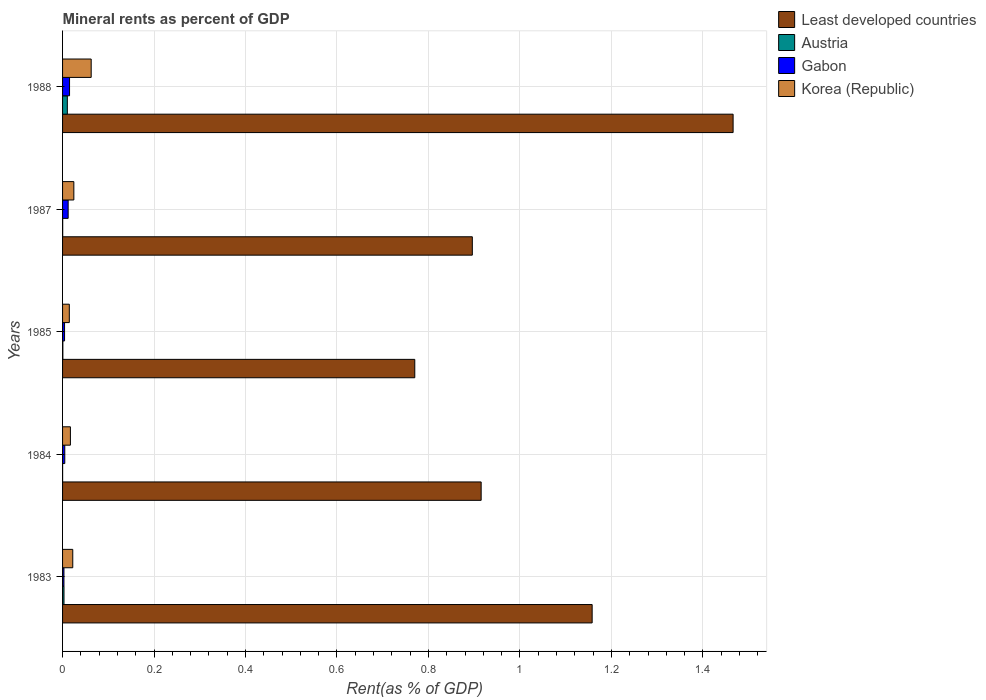How many different coloured bars are there?
Your answer should be very brief. 4. How many groups of bars are there?
Provide a succinct answer. 5. Are the number of bars on each tick of the Y-axis equal?
Provide a short and direct response. Yes. How many bars are there on the 3rd tick from the top?
Make the answer very short. 4. What is the label of the 2nd group of bars from the top?
Give a very brief answer. 1987. In how many cases, is the number of bars for a given year not equal to the number of legend labels?
Offer a very short reply. 0. What is the mineral rent in Least developed countries in 1987?
Your response must be concise. 0.9. Across all years, what is the maximum mineral rent in Least developed countries?
Offer a very short reply. 1.47. Across all years, what is the minimum mineral rent in Austria?
Provide a succinct answer. 8.70112299928104e-5. What is the total mineral rent in Least developed countries in the graph?
Give a very brief answer. 5.21. What is the difference between the mineral rent in Least developed countries in 1984 and that in 1987?
Keep it short and to the point. 0.02. What is the difference between the mineral rent in Korea (Republic) in 1988 and the mineral rent in Least developed countries in 1984?
Give a very brief answer. -0.85. What is the average mineral rent in Korea (Republic) per year?
Make the answer very short. 0.03. In the year 1985, what is the difference between the mineral rent in Gabon and mineral rent in Austria?
Offer a terse response. 0. What is the ratio of the mineral rent in Austria in 1987 to that in 1988?
Provide a short and direct response. 0.02. What is the difference between the highest and the second highest mineral rent in Korea (Republic)?
Your response must be concise. 0.04. What is the difference between the highest and the lowest mineral rent in Korea (Republic)?
Provide a succinct answer. 0.05. In how many years, is the mineral rent in Gabon greater than the average mineral rent in Gabon taken over all years?
Your response must be concise. 2. Is the sum of the mineral rent in Gabon in 1983 and 1984 greater than the maximum mineral rent in Korea (Republic) across all years?
Offer a terse response. No. Is it the case that in every year, the sum of the mineral rent in Korea (Republic) and mineral rent in Gabon is greater than the sum of mineral rent in Least developed countries and mineral rent in Austria?
Offer a terse response. Yes. What does the 4th bar from the bottom in 1983 represents?
Ensure brevity in your answer.  Korea (Republic). How many bars are there?
Provide a succinct answer. 20. How many years are there in the graph?
Offer a terse response. 5. How are the legend labels stacked?
Give a very brief answer. Vertical. What is the title of the graph?
Give a very brief answer. Mineral rents as percent of GDP. What is the label or title of the X-axis?
Your response must be concise. Rent(as % of GDP). What is the Rent(as % of GDP) in Least developed countries in 1983?
Your answer should be compact. 1.16. What is the Rent(as % of GDP) of Austria in 1983?
Your answer should be very brief. 0. What is the Rent(as % of GDP) in Gabon in 1983?
Provide a succinct answer. 0. What is the Rent(as % of GDP) in Korea (Republic) in 1983?
Provide a succinct answer. 0.02. What is the Rent(as % of GDP) in Least developed countries in 1984?
Ensure brevity in your answer.  0.92. What is the Rent(as % of GDP) in Austria in 1984?
Your answer should be compact. 8.70112299928104e-5. What is the Rent(as % of GDP) of Gabon in 1984?
Give a very brief answer. 0. What is the Rent(as % of GDP) in Korea (Republic) in 1984?
Your response must be concise. 0.02. What is the Rent(as % of GDP) of Least developed countries in 1985?
Your answer should be very brief. 0.77. What is the Rent(as % of GDP) in Austria in 1985?
Offer a terse response. 0. What is the Rent(as % of GDP) of Gabon in 1985?
Give a very brief answer. 0. What is the Rent(as % of GDP) of Korea (Republic) in 1985?
Your answer should be compact. 0.01. What is the Rent(as % of GDP) in Least developed countries in 1987?
Your answer should be compact. 0.9. What is the Rent(as % of GDP) of Austria in 1987?
Your answer should be very brief. 0. What is the Rent(as % of GDP) in Gabon in 1987?
Offer a very short reply. 0.01. What is the Rent(as % of GDP) in Korea (Republic) in 1987?
Ensure brevity in your answer.  0.02. What is the Rent(as % of GDP) of Least developed countries in 1988?
Offer a very short reply. 1.47. What is the Rent(as % of GDP) in Austria in 1988?
Your answer should be compact. 0.01. What is the Rent(as % of GDP) in Gabon in 1988?
Offer a very short reply. 0.02. What is the Rent(as % of GDP) in Korea (Republic) in 1988?
Your response must be concise. 0.06. Across all years, what is the maximum Rent(as % of GDP) in Least developed countries?
Keep it short and to the point. 1.47. Across all years, what is the maximum Rent(as % of GDP) of Austria?
Make the answer very short. 0.01. Across all years, what is the maximum Rent(as % of GDP) of Gabon?
Your response must be concise. 0.02. Across all years, what is the maximum Rent(as % of GDP) of Korea (Republic)?
Provide a succinct answer. 0.06. Across all years, what is the minimum Rent(as % of GDP) of Least developed countries?
Provide a short and direct response. 0.77. Across all years, what is the minimum Rent(as % of GDP) in Austria?
Give a very brief answer. 8.70112299928104e-5. Across all years, what is the minimum Rent(as % of GDP) of Gabon?
Keep it short and to the point. 0. Across all years, what is the minimum Rent(as % of GDP) in Korea (Republic)?
Your answer should be compact. 0.01. What is the total Rent(as % of GDP) in Least developed countries in the graph?
Offer a terse response. 5.21. What is the total Rent(as % of GDP) of Austria in the graph?
Ensure brevity in your answer.  0.01. What is the total Rent(as % of GDP) in Gabon in the graph?
Ensure brevity in your answer.  0.04. What is the total Rent(as % of GDP) in Korea (Republic) in the graph?
Your response must be concise. 0.14. What is the difference between the Rent(as % of GDP) in Least developed countries in 1983 and that in 1984?
Your response must be concise. 0.24. What is the difference between the Rent(as % of GDP) in Austria in 1983 and that in 1984?
Your response must be concise. 0. What is the difference between the Rent(as % of GDP) in Gabon in 1983 and that in 1984?
Your response must be concise. -0. What is the difference between the Rent(as % of GDP) in Korea (Republic) in 1983 and that in 1984?
Ensure brevity in your answer.  0.01. What is the difference between the Rent(as % of GDP) of Least developed countries in 1983 and that in 1985?
Give a very brief answer. 0.39. What is the difference between the Rent(as % of GDP) in Austria in 1983 and that in 1985?
Provide a succinct answer. 0. What is the difference between the Rent(as % of GDP) in Gabon in 1983 and that in 1985?
Provide a succinct answer. -0. What is the difference between the Rent(as % of GDP) of Korea (Republic) in 1983 and that in 1985?
Your response must be concise. 0.01. What is the difference between the Rent(as % of GDP) in Least developed countries in 1983 and that in 1987?
Offer a very short reply. 0.26. What is the difference between the Rent(as % of GDP) of Austria in 1983 and that in 1987?
Your answer should be very brief. 0. What is the difference between the Rent(as % of GDP) in Gabon in 1983 and that in 1987?
Offer a very short reply. -0.01. What is the difference between the Rent(as % of GDP) in Korea (Republic) in 1983 and that in 1987?
Offer a very short reply. -0. What is the difference between the Rent(as % of GDP) in Least developed countries in 1983 and that in 1988?
Offer a very short reply. -0.31. What is the difference between the Rent(as % of GDP) in Austria in 1983 and that in 1988?
Keep it short and to the point. -0.01. What is the difference between the Rent(as % of GDP) in Gabon in 1983 and that in 1988?
Give a very brief answer. -0.01. What is the difference between the Rent(as % of GDP) in Korea (Republic) in 1983 and that in 1988?
Ensure brevity in your answer.  -0.04. What is the difference between the Rent(as % of GDP) in Least developed countries in 1984 and that in 1985?
Keep it short and to the point. 0.15. What is the difference between the Rent(as % of GDP) in Austria in 1984 and that in 1985?
Keep it short and to the point. -0. What is the difference between the Rent(as % of GDP) of Korea (Republic) in 1984 and that in 1985?
Offer a terse response. 0. What is the difference between the Rent(as % of GDP) in Least developed countries in 1984 and that in 1987?
Keep it short and to the point. 0.02. What is the difference between the Rent(as % of GDP) of Austria in 1984 and that in 1987?
Your answer should be very brief. -0. What is the difference between the Rent(as % of GDP) in Gabon in 1984 and that in 1987?
Keep it short and to the point. -0.01. What is the difference between the Rent(as % of GDP) of Korea (Republic) in 1984 and that in 1987?
Keep it short and to the point. -0.01. What is the difference between the Rent(as % of GDP) of Least developed countries in 1984 and that in 1988?
Your answer should be compact. -0.55. What is the difference between the Rent(as % of GDP) of Austria in 1984 and that in 1988?
Your answer should be very brief. -0.01. What is the difference between the Rent(as % of GDP) in Gabon in 1984 and that in 1988?
Provide a short and direct response. -0.01. What is the difference between the Rent(as % of GDP) in Korea (Republic) in 1984 and that in 1988?
Offer a very short reply. -0.05. What is the difference between the Rent(as % of GDP) of Least developed countries in 1985 and that in 1987?
Make the answer very short. -0.13. What is the difference between the Rent(as % of GDP) of Austria in 1985 and that in 1987?
Ensure brevity in your answer.  0. What is the difference between the Rent(as % of GDP) in Gabon in 1985 and that in 1987?
Your response must be concise. -0.01. What is the difference between the Rent(as % of GDP) in Korea (Republic) in 1985 and that in 1987?
Give a very brief answer. -0.01. What is the difference between the Rent(as % of GDP) in Least developed countries in 1985 and that in 1988?
Make the answer very short. -0.7. What is the difference between the Rent(as % of GDP) of Austria in 1985 and that in 1988?
Provide a short and direct response. -0.01. What is the difference between the Rent(as % of GDP) of Gabon in 1985 and that in 1988?
Make the answer very short. -0.01. What is the difference between the Rent(as % of GDP) of Korea (Republic) in 1985 and that in 1988?
Offer a very short reply. -0.05. What is the difference between the Rent(as % of GDP) in Least developed countries in 1987 and that in 1988?
Offer a terse response. -0.57. What is the difference between the Rent(as % of GDP) of Austria in 1987 and that in 1988?
Provide a succinct answer. -0.01. What is the difference between the Rent(as % of GDP) in Gabon in 1987 and that in 1988?
Make the answer very short. -0. What is the difference between the Rent(as % of GDP) of Korea (Republic) in 1987 and that in 1988?
Provide a succinct answer. -0.04. What is the difference between the Rent(as % of GDP) of Least developed countries in 1983 and the Rent(as % of GDP) of Austria in 1984?
Make the answer very short. 1.16. What is the difference between the Rent(as % of GDP) in Least developed countries in 1983 and the Rent(as % of GDP) in Gabon in 1984?
Keep it short and to the point. 1.15. What is the difference between the Rent(as % of GDP) in Least developed countries in 1983 and the Rent(as % of GDP) in Korea (Republic) in 1984?
Make the answer very short. 1.14. What is the difference between the Rent(as % of GDP) of Austria in 1983 and the Rent(as % of GDP) of Gabon in 1984?
Offer a very short reply. -0. What is the difference between the Rent(as % of GDP) of Austria in 1983 and the Rent(as % of GDP) of Korea (Republic) in 1984?
Keep it short and to the point. -0.01. What is the difference between the Rent(as % of GDP) of Gabon in 1983 and the Rent(as % of GDP) of Korea (Republic) in 1984?
Your answer should be very brief. -0.01. What is the difference between the Rent(as % of GDP) in Least developed countries in 1983 and the Rent(as % of GDP) in Austria in 1985?
Provide a succinct answer. 1.16. What is the difference between the Rent(as % of GDP) in Least developed countries in 1983 and the Rent(as % of GDP) in Gabon in 1985?
Provide a succinct answer. 1.15. What is the difference between the Rent(as % of GDP) in Least developed countries in 1983 and the Rent(as % of GDP) in Korea (Republic) in 1985?
Make the answer very short. 1.14. What is the difference between the Rent(as % of GDP) in Austria in 1983 and the Rent(as % of GDP) in Gabon in 1985?
Keep it short and to the point. -0. What is the difference between the Rent(as % of GDP) in Austria in 1983 and the Rent(as % of GDP) in Korea (Republic) in 1985?
Provide a succinct answer. -0.01. What is the difference between the Rent(as % of GDP) of Gabon in 1983 and the Rent(as % of GDP) of Korea (Republic) in 1985?
Your response must be concise. -0.01. What is the difference between the Rent(as % of GDP) of Least developed countries in 1983 and the Rent(as % of GDP) of Austria in 1987?
Provide a succinct answer. 1.16. What is the difference between the Rent(as % of GDP) in Least developed countries in 1983 and the Rent(as % of GDP) in Gabon in 1987?
Ensure brevity in your answer.  1.15. What is the difference between the Rent(as % of GDP) in Least developed countries in 1983 and the Rent(as % of GDP) in Korea (Republic) in 1987?
Provide a short and direct response. 1.13. What is the difference between the Rent(as % of GDP) of Austria in 1983 and the Rent(as % of GDP) of Gabon in 1987?
Make the answer very short. -0.01. What is the difference between the Rent(as % of GDP) of Austria in 1983 and the Rent(as % of GDP) of Korea (Republic) in 1987?
Your response must be concise. -0.02. What is the difference between the Rent(as % of GDP) of Gabon in 1983 and the Rent(as % of GDP) of Korea (Republic) in 1987?
Offer a very short reply. -0.02. What is the difference between the Rent(as % of GDP) in Least developed countries in 1983 and the Rent(as % of GDP) in Austria in 1988?
Provide a short and direct response. 1.15. What is the difference between the Rent(as % of GDP) in Least developed countries in 1983 and the Rent(as % of GDP) in Gabon in 1988?
Give a very brief answer. 1.14. What is the difference between the Rent(as % of GDP) of Least developed countries in 1983 and the Rent(as % of GDP) of Korea (Republic) in 1988?
Ensure brevity in your answer.  1.1. What is the difference between the Rent(as % of GDP) of Austria in 1983 and the Rent(as % of GDP) of Gabon in 1988?
Your answer should be compact. -0.01. What is the difference between the Rent(as % of GDP) of Austria in 1983 and the Rent(as % of GDP) of Korea (Republic) in 1988?
Offer a terse response. -0.06. What is the difference between the Rent(as % of GDP) of Gabon in 1983 and the Rent(as % of GDP) of Korea (Republic) in 1988?
Offer a terse response. -0.06. What is the difference between the Rent(as % of GDP) of Least developed countries in 1984 and the Rent(as % of GDP) of Austria in 1985?
Provide a short and direct response. 0.91. What is the difference between the Rent(as % of GDP) of Least developed countries in 1984 and the Rent(as % of GDP) of Gabon in 1985?
Ensure brevity in your answer.  0.91. What is the difference between the Rent(as % of GDP) of Least developed countries in 1984 and the Rent(as % of GDP) of Korea (Republic) in 1985?
Offer a terse response. 0.9. What is the difference between the Rent(as % of GDP) of Austria in 1984 and the Rent(as % of GDP) of Gabon in 1985?
Offer a terse response. -0. What is the difference between the Rent(as % of GDP) of Austria in 1984 and the Rent(as % of GDP) of Korea (Republic) in 1985?
Your answer should be compact. -0.01. What is the difference between the Rent(as % of GDP) of Gabon in 1984 and the Rent(as % of GDP) of Korea (Republic) in 1985?
Ensure brevity in your answer.  -0.01. What is the difference between the Rent(as % of GDP) of Least developed countries in 1984 and the Rent(as % of GDP) of Austria in 1987?
Your response must be concise. 0.92. What is the difference between the Rent(as % of GDP) in Least developed countries in 1984 and the Rent(as % of GDP) in Gabon in 1987?
Ensure brevity in your answer.  0.9. What is the difference between the Rent(as % of GDP) of Least developed countries in 1984 and the Rent(as % of GDP) of Korea (Republic) in 1987?
Provide a succinct answer. 0.89. What is the difference between the Rent(as % of GDP) in Austria in 1984 and the Rent(as % of GDP) in Gabon in 1987?
Offer a terse response. -0.01. What is the difference between the Rent(as % of GDP) in Austria in 1984 and the Rent(as % of GDP) in Korea (Republic) in 1987?
Offer a very short reply. -0.02. What is the difference between the Rent(as % of GDP) in Gabon in 1984 and the Rent(as % of GDP) in Korea (Republic) in 1987?
Your response must be concise. -0.02. What is the difference between the Rent(as % of GDP) in Least developed countries in 1984 and the Rent(as % of GDP) in Austria in 1988?
Ensure brevity in your answer.  0.9. What is the difference between the Rent(as % of GDP) in Least developed countries in 1984 and the Rent(as % of GDP) in Gabon in 1988?
Your answer should be very brief. 0.9. What is the difference between the Rent(as % of GDP) in Least developed countries in 1984 and the Rent(as % of GDP) in Korea (Republic) in 1988?
Keep it short and to the point. 0.85. What is the difference between the Rent(as % of GDP) of Austria in 1984 and the Rent(as % of GDP) of Gabon in 1988?
Keep it short and to the point. -0.02. What is the difference between the Rent(as % of GDP) of Austria in 1984 and the Rent(as % of GDP) of Korea (Republic) in 1988?
Your response must be concise. -0.06. What is the difference between the Rent(as % of GDP) of Gabon in 1984 and the Rent(as % of GDP) of Korea (Republic) in 1988?
Your response must be concise. -0.06. What is the difference between the Rent(as % of GDP) of Least developed countries in 1985 and the Rent(as % of GDP) of Austria in 1987?
Give a very brief answer. 0.77. What is the difference between the Rent(as % of GDP) of Least developed countries in 1985 and the Rent(as % of GDP) of Gabon in 1987?
Make the answer very short. 0.76. What is the difference between the Rent(as % of GDP) in Least developed countries in 1985 and the Rent(as % of GDP) in Korea (Republic) in 1987?
Offer a terse response. 0.75. What is the difference between the Rent(as % of GDP) in Austria in 1985 and the Rent(as % of GDP) in Gabon in 1987?
Provide a short and direct response. -0.01. What is the difference between the Rent(as % of GDP) in Austria in 1985 and the Rent(as % of GDP) in Korea (Republic) in 1987?
Offer a terse response. -0.02. What is the difference between the Rent(as % of GDP) of Gabon in 1985 and the Rent(as % of GDP) of Korea (Republic) in 1987?
Provide a short and direct response. -0.02. What is the difference between the Rent(as % of GDP) in Least developed countries in 1985 and the Rent(as % of GDP) in Austria in 1988?
Make the answer very short. 0.76. What is the difference between the Rent(as % of GDP) of Least developed countries in 1985 and the Rent(as % of GDP) of Gabon in 1988?
Provide a short and direct response. 0.75. What is the difference between the Rent(as % of GDP) in Least developed countries in 1985 and the Rent(as % of GDP) in Korea (Republic) in 1988?
Provide a short and direct response. 0.71. What is the difference between the Rent(as % of GDP) of Austria in 1985 and the Rent(as % of GDP) of Gabon in 1988?
Provide a succinct answer. -0.01. What is the difference between the Rent(as % of GDP) of Austria in 1985 and the Rent(as % of GDP) of Korea (Republic) in 1988?
Make the answer very short. -0.06. What is the difference between the Rent(as % of GDP) in Gabon in 1985 and the Rent(as % of GDP) in Korea (Republic) in 1988?
Keep it short and to the point. -0.06. What is the difference between the Rent(as % of GDP) in Least developed countries in 1987 and the Rent(as % of GDP) in Austria in 1988?
Offer a terse response. 0.89. What is the difference between the Rent(as % of GDP) in Least developed countries in 1987 and the Rent(as % of GDP) in Gabon in 1988?
Keep it short and to the point. 0.88. What is the difference between the Rent(as % of GDP) of Least developed countries in 1987 and the Rent(as % of GDP) of Korea (Republic) in 1988?
Offer a very short reply. 0.83. What is the difference between the Rent(as % of GDP) in Austria in 1987 and the Rent(as % of GDP) in Gabon in 1988?
Your answer should be very brief. -0.01. What is the difference between the Rent(as % of GDP) in Austria in 1987 and the Rent(as % of GDP) in Korea (Republic) in 1988?
Offer a terse response. -0.06. What is the difference between the Rent(as % of GDP) in Gabon in 1987 and the Rent(as % of GDP) in Korea (Republic) in 1988?
Keep it short and to the point. -0.05. What is the average Rent(as % of GDP) in Least developed countries per year?
Your answer should be very brief. 1.04. What is the average Rent(as % of GDP) of Austria per year?
Your answer should be compact. 0. What is the average Rent(as % of GDP) in Gabon per year?
Provide a succinct answer. 0.01. What is the average Rent(as % of GDP) of Korea (Republic) per year?
Ensure brevity in your answer.  0.03. In the year 1983, what is the difference between the Rent(as % of GDP) of Least developed countries and Rent(as % of GDP) of Austria?
Ensure brevity in your answer.  1.15. In the year 1983, what is the difference between the Rent(as % of GDP) in Least developed countries and Rent(as % of GDP) in Gabon?
Offer a terse response. 1.15. In the year 1983, what is the difference between the Rent(as % of GDP) in Least developed countries and Rent(as % of GDP) in Korea (Republic)?
Keep it short and to the point. 1.14. In the year 1983, what is the difference between the Rent(as % of GDP) of Austria and Rent(as % of GDP) of Korea (Republic)?
Ensure brevity in your answer.  -0.02. In the year 1983, what is the difference between the Rent(as % of GDP) in Gabon and Rent(as % of GDP) in Korea (Republic)?
Keep it short and to the point. -0.02. In the year 1984, what is the difference between the Rent(as % of GDP) in Least developed countries and Rent(as % of GDP) in Austria?
Your answer should be compact. 0.92. In the year 1984, what is the difference between the Rent(as % of GDP) of Least developed countries and Rent(as % of GDP) of Gabon?
Your answer should be compact. 0.91. In the year 1984, what is the difference between the Rent(as % of GDP) in Least developed countries and Rent(as % of GDP) in Korea (Republic)?
Your response must be concise. 0.9. In the year 1984, what is the difference between the Rent(as % of GDP) of Austria and Rent(as % of GDP) of Gabon?
Give a very brief answer. -0. In the year 1984, what is the difference between the Rent(as % of GDP) of Austria and Rent(as % of GDP) of Korea (Republic)?
Offer a terse response. -0.02. In the year 1984, what is the difference between the Rent(as % of GDP) of Gabon and Rent(as % of GDP) of Korea (Republic)?
Offer a very short reply. -0.01. In the year 1985, what is the difference between the Rent(as % of GDP) in Least developed countries and Rent(as % of GDP) in Austria?
Provide a succinct answer. 0.77. In the year 1985, what is the difference between the Rent(as % of GDP) in Least developed countries and Rent(as % of GDP) in Gabon?
Your response must be concise. 0.77. In the year 1985, what is the difference between the Rent(as % of GDP) in Least developed countries and Rent(as % of GDP) in Korea (Republic)?
Your answer should be compact. 0.76. In the year 1985, what is the difference between the Rent(as % of GDP) of Austria and Rent(as % of GDP) of Gabon?
Your answer should be very brief. -0. In the year 1985, what is the difference between the Rent(as % of GDP) of Austria and Rent(as % of GDP) of Korea (Republic)?
Provide a succinct answer. -0.01. In the year 1985, what is the difference between the Rent(as % of GDP) of Gabon and Rent(as % of GDP) of Korea (Republic)?
Your answer should be very brief. -0.01. In the year 1987, what is the difference between the Rent(as % of GDP) in Least developed countries and Rent(as % of GDP) in Austria?
Offer a terse response. 0.9. In the year 1987, what is the difference between the Rent(as % of GDP) of Least developed countries and Rent(as % of GDP) of Gabon?
Provide a succinct answer. 0.88. In the year 1987, what is the difference between the Rent(as % of GDP) of Least developed countries and Rent(as % of GDP) of Korea (Republic)?
Provide a succinct answer. 0.87. In the year 1987, what is the difference between the Rent(as % of GDP) of Austria and Rent(as % of GDP) of Gabon?
Give a very brief answer. -0.01. In the year 1987, what is the difference between the Rent(as % of GDP) in Austria and Rent(as % of GDP) in Korea (Republic)?
Keep it short and to the point. -0.02. In the year 1987, what is the difference between the Rent(as % of GDP) of Gabon and Rent(as % of GDP) of Korea (Republic)?
Ensure brevity in your answer.  -0.01. In the year 1988, what is the difference between the Rent(as % of GDP) in Least developed countries and Rent(as % of GDP) in Austria?
Provide a succinct answer. 1.46. In the year 1988, what is the difference between the Rent(as % of GDP) of Least developed countries and Rent(as % of GDP) of Gabon?
Your answer should be very brief. 1.45. In the year 1988, what is the difference between the Rent(as % of GDP) in Least developed countries and Rent(as % of GDP) in Korea (Republic)?
Your answer should be very brief. 1.4. In the year 1988, what is the difference between the Rent(as % of GDP) in Austria and Rent(as % of GDP) in Gabon?
Ensure brevity in your answer.  -0. In the year 1988, what is the difference between the Rent(as % of GDP) in Austria and Rent(as % of GDP) in Korea (Republic)?
Provide a short and direct response. -0.05. In the year 1988, what is the difference between the Rent(as % of GDP) in Gabon and Rent(as % of GDP) in Korea (Republic)?
Keep it short and to the point. -0.05. What is the ratio of the Rent(as % of GDP) in Least developed countries in 1983 to that in 1984?
Keep it short and to the point. 1.27. What is the ratio of the Rent(as % of GDP) in Austria in 1983 to that in 1984?
Ensure brevity in your answer.  36.2. What is the ratio of the Rent(as % of GDP) of Gabon in 1983 to that in 1984?
Make the answer very short. 0.62. What is the ratio of the Rent(as % of GDP) of Korea (Republic) in 1983 to that in 1984?
Keep it short and to the point. 1.3. What is the ratio of the Rent(as % of GDP) of Least developed countries in 1983 to that in 1985?
Offer a very short reply. 1.5. What is the ratio of the Rent(as % of GDP) of Austria in 1983 to that in 1985?
Your answer should be compact. 4.79. What is the ratio of the Rent(as % of GDP) in Gabon in 1983 to that in 1985?
Your answer should be very brief. 0.69. What is the ratio of the Rent(as % of GDP) of Korea (Republic) in 1983 to that in 1985?
Ensure brevity in your answer.  1.51. What is the ratio of the Rent(as % of GDP) of Least developed countries in 1983 to that in 1987?
Keep it short and to the point. 1.29. What is the ratio of the Rent(as % of GDP) of Austria in 1983 to that in 1987?
Keep it short and to the point. 12.35. What is the ratio of the Rent(as % of GDP) in Gabon in 1983 to that in 1987?
Ensure brevity in your answer.  0.25. What is the ratio of the Rent(as % of GDP) of Korea (Republic) in 1983 to that in 1987?
Offer a terse response. 0.91. What is the ratio of the Rent(as % of GDP) of Least developed countries in 1983 to that in 1988?
Keep it short and to the point. 0.79. What is the ratio of the Rent(as % of GDP) in Austria in 1983 to that in 1988?
Offer a very short reply. 0.3. What is the ratio of the Rent(as % of GDP) in Gabon in 1983 to that in 1988?
Your answer should be compact. 0.2. What is the ratio of the Rent(as % of GDP) of Korea (Republic) in 1983 to that in 1988?
Give a very brief answer. 0.36. What is the ratio of the Rent(as % of GDP) in Least developed countries in 1984 to that in 1985?
Provide a succinct answer. 1.19. What is the ratio of the Rent(as % of GDP) of Austria in 1984 to that in 1985?
Keep it short and to the point. 0.13. What is the ratio of the Rent(as % of GDP) of Gabon in 1984 to that in 1985?
Give a very brief answer. 1.11. What is the ratio of the Rent(as % of GDP) of Korea (Republic) in 1984 to that in 1985?
Your response must be concise. 1.16. What is the ratio of the Rent(as % of GDP) in Least developed countries in 1984 to that in 1987?
Keep it short and to the point. 1.02. What is the ratio of the Rent(as % of GDP) in Austria in 1984 to that in 1987?
Your answer should be compact. 0.34. What is the ratio of the Rent(as % of GDP) in Gabon in 1984 to that in 1987?
Your answer should be very brief. 0.4. What is the ratio of the Rent(as % of GDP) in Korea (Republic) in 1984 to that in 1987?
Provide a short and direct response. 0.7. What is the ratio of the Rent(as % of GDP) of Least developed countries in 1984 to that in 1988?
Your answer should be compact. 0.62. What is the ratio of the Rent(as % of GDP) of Austria in 1984 to that in 1988?
Your answer should be very brief. 0.01. What is the ratio of the Rent(as % of GDP) of Gabon in 1984 to that in 1988?
Provide a short and direct response. 0.32. What is the ratio of the Rent(as % of GDP) in Korea (Republic) in 1984 to that in 1988?
Ensure brevity in your answer.  0.27. What is the ratio of the Rent(as % of GDP) in Least developed countries in 1985 to that in 1987?
Give a very brief answer. 0.86. What is the ratio of the Rent(as % of GDP) in Austria in 1985 to that in 1987?
Ensure brevity in your answer.  2.58. What is the ratio of the Rent(as % of GDP) in Gabon in 1985 to that in 1987?
Your answer should be very brief. 0.36. What is the ratio of the Rent(as % of GDP) in Korea (Republic) in 1985 to that in 1987?
Give a very brief answer. 0.6. What is the ratio of the Rent(as % of GDP) of Least developed countries in 1985 to that in 1988?
Ensure brevity in your answer.  0.53. What is the ratio of the Rent(as % of GDP) of Austria in 1985 to that in 1988?
Provide a succinct answer. 0.06. What is the ratio of the Rent(as % of GDP) in Gabon in 1985 to that in 1988?
Provide a short and direct response. 0.29. What is the ratio of the Rent(as % of GDP) of Korea (Republic) in 1985 to that in 1988?
Offer a very short reply. 0.24. What is the ratio of the Rent(as % of GDP) of Least developed countries in 1987 to that in 1988?
Your answer should be compact. 0.61. What is the ratio of the Rent(as % of GDP) of Austria in 1987 to that in 1988?
Provide a short and direct response. 0.02. What is the ratio of the Rent(as % of GDP) of Gabon in 1987 to that in 1988?
Provide a short and direct response. 0.8. What is the ratio of the Rent(as % of GDP) of Korea (Republic) in 1987 to that in 1988?
Make the answer very short. 0.39. What is the difference between the highest and the second highest Rent(as % of GDP) of Least developed countries?
Keep it short and to the point. 0.31. What is the difference between the highest and the second highest Rent(as % of GDP) of Austria?
Give a very brief answer. 0.01. What is the difference between the highest and the second highest Rent(as % of GDP) in Gabon?
Keep it short and to the point. 0. What is the difference between the highest and the second highest Rent(as % of GDP) of Korea (Republic)?
Make the answer very short. 0.04. What is the difference between the highest and the lowest Rent(as % of GDP) in Least developed countries?
Your answer should be compact. 0.7. What is the difference between the highest and the lowest Rent(as % of GDP) of Austria?
Offer a very short reply. 0.01. What is the difference between the highest and the lowest Rent(as % of GDP) of Gabon?
Offer a terse response. 0.01. What is the difference between the highest and the lowest Rent(as % of GDP) of Korea (Republic)?
Provide a succinct answer. 0.05. 